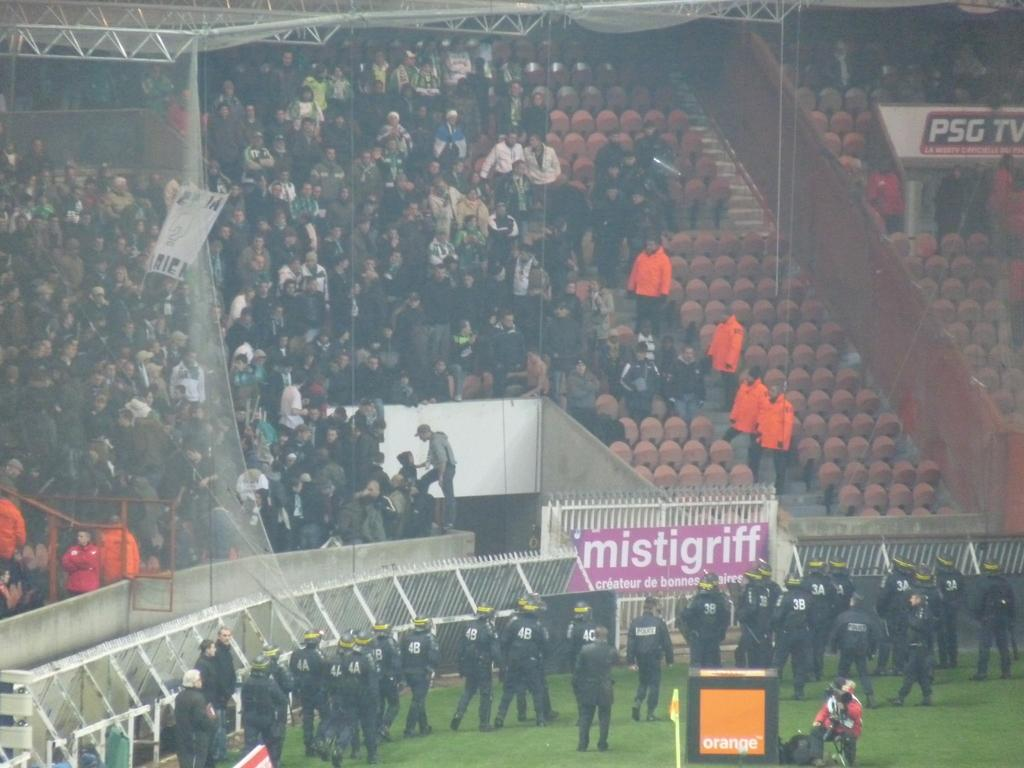What is the main subject of the image? The main subject of the image is a crowd. Can you describe the people in the crowd? Some persons are standing in the crowd. What are the persons in the crowd wearing? The persons in the crowd are wearing clothes. What type of ground can be seen beneath the crowd in the image? There is no specific ground visible beneath the crowd in the image; it is not possible to determine the type of ground from the image alone. 